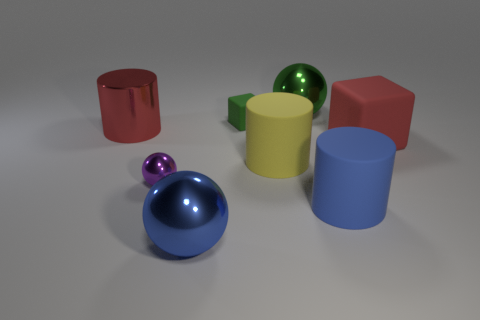There is a big sphere that is behind the blue cylinder; how many big objects are behind it?
Offer a very short reply. 0. Does the small purple sphere that is on the left side of the big red matte object have the same material as the small thing behind the red rubber thing?
Make the answer very short. No. There is a thing that is the same color as the metallic cylinder; what material is it?
Offer a very short reply. Rubber. What number of yellow rubber things are the same shape as the red metallic thing?
Ensure brevity in your answer.  1. Do the blue cylinder and the object on the left side of the purple thing have the same material?
Make the answer very short. No. There is a red block that is the same size as the blue sphere; what is it made of?
Your answer should be very brief. Rubber. Is there a brown rubber block that has the same size as the purple shiny thing?
Keep it short and to the point. No. There is a red rubber object that is the same size as the yellow thing; what is its shape?
Your answer should be very brief. Cube. How many other things are the same color as the large rubber block?
Keep it short and to the point. 1. What shape is the rubber thing that is both left of the green ball and in front of the metallic cylinder?
Your answer should be compact. Cylinder. 